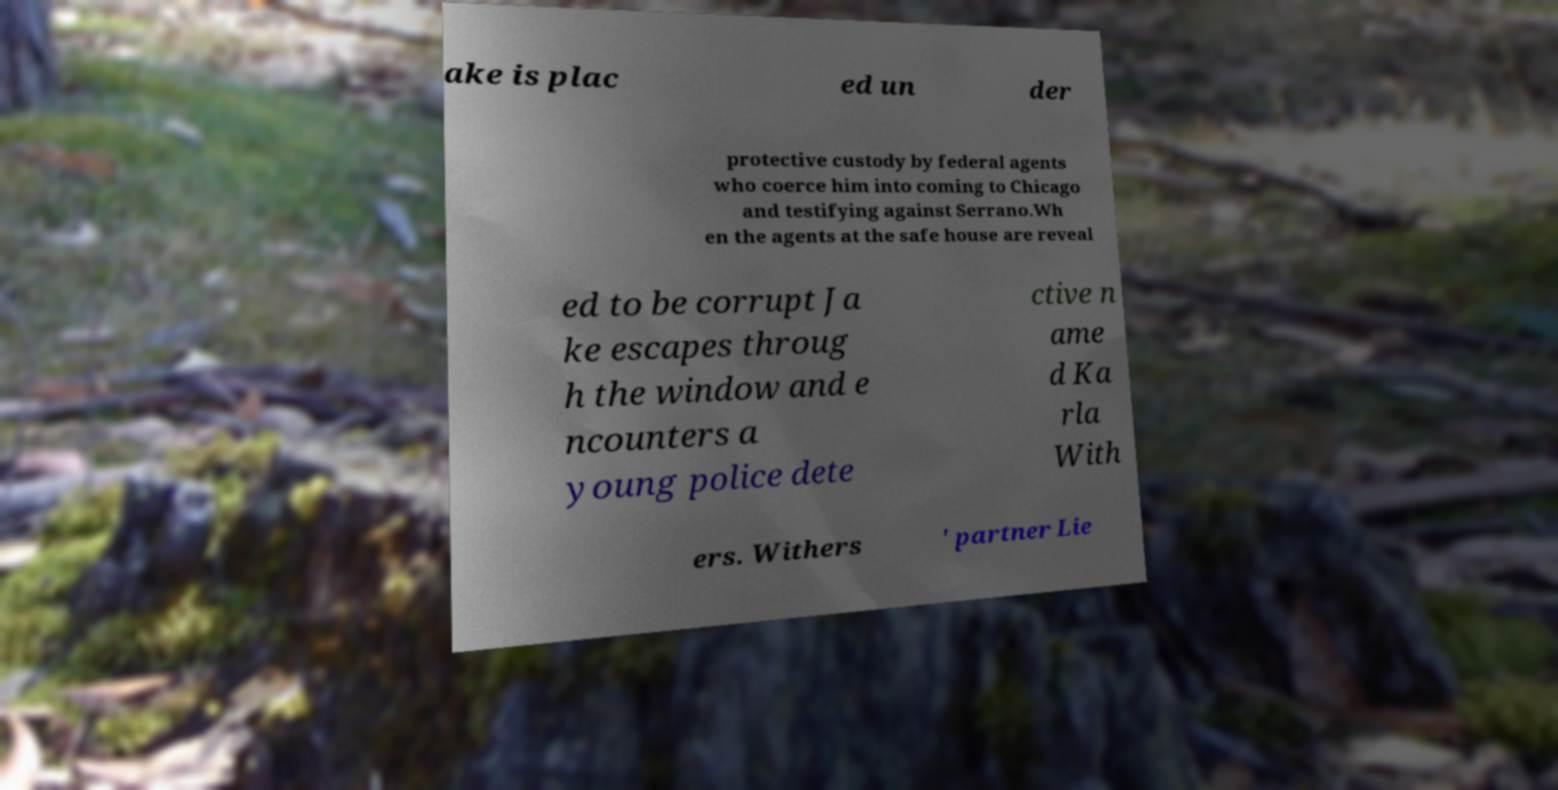Could you assist in decoding the text presented in this image and type it out clearly? ake is plac ed un der protective custody by federal agents who coerce him into coming to Chicago and testifying against Serrano.Wh en the agents at the safe house are reveal ed to be corrupt Ja ke escapes throug h the window and e ncounters a young police dete ctive n ame d Ka rla With ers. Withers ' partner Lie 